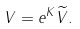<formula> <loc_0><loc_0><loc_500><loc_500>V = e ^ { K } \widetilde { V } .</formula> 